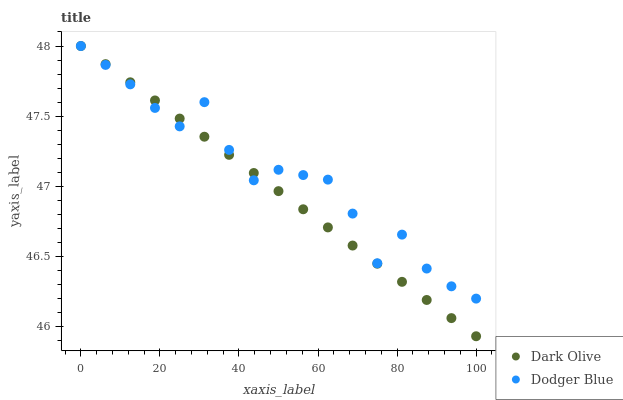Does Dark Olive have the minimum area under the curve?
Answer yes or no. Yes. Does Dodger Blue have the maximum area under the curve?
Answer yes or no. Yes. Does Dodger Blue have the minimum area under the curve?
Answer yes or no. No. Is Dark Olive the smoothest?
Answer yes or no. Yes. Is Dodger Blue the roughest?
Answer yes or no. Yes. Is Dodger Blue the smoothest?
Answer yes or no. No. Does Dark Olive have the lowest value?
Answer yes or no. Yes. Does Dodger Blue have the lowest value?
Answer yes or no. No. Does Dodger Blue have the highest value?
Answer yes or no. Yes. Does Dodger Blue intersect Dark Olive?
Answer yes or no. Yes. Is Dodger Blue less than Dark Olive?
Answer yes or no. No. Is Dodger Blue greater than Dark Olive?
Answer yes or no. No. 